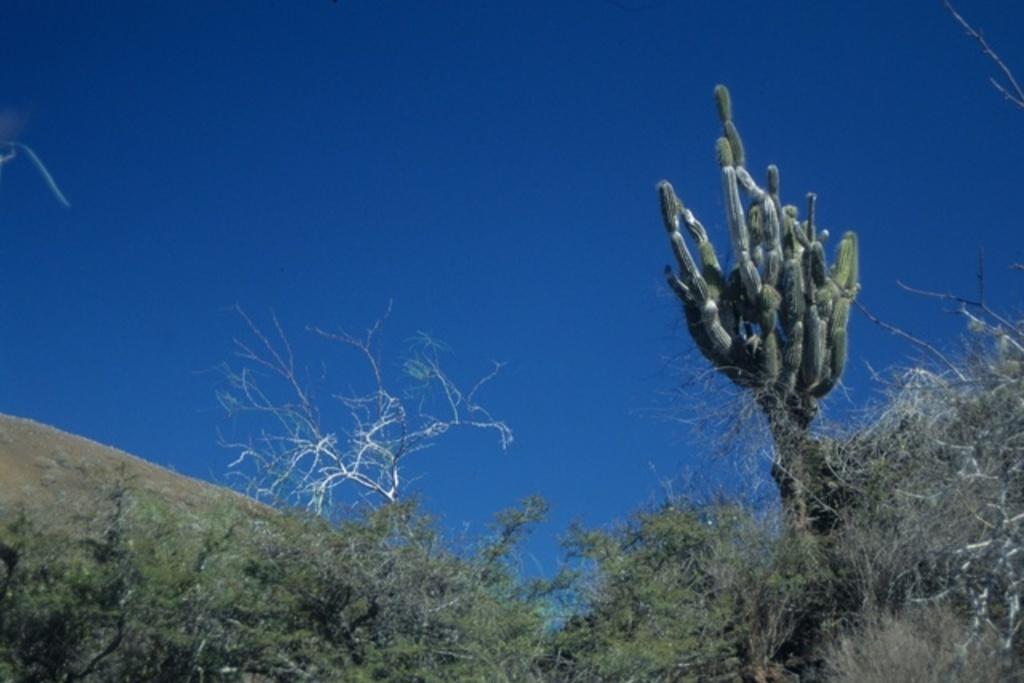What type of vegetation can be seen in the image? There is a group of trees and a cactus in the image. What can be seen in the background of the image? The sky is visible in the background of the image. Which month is the actor performing in the image? There is no actor or performance present in the image; it features a group of trees, a cactus, and the sky. 